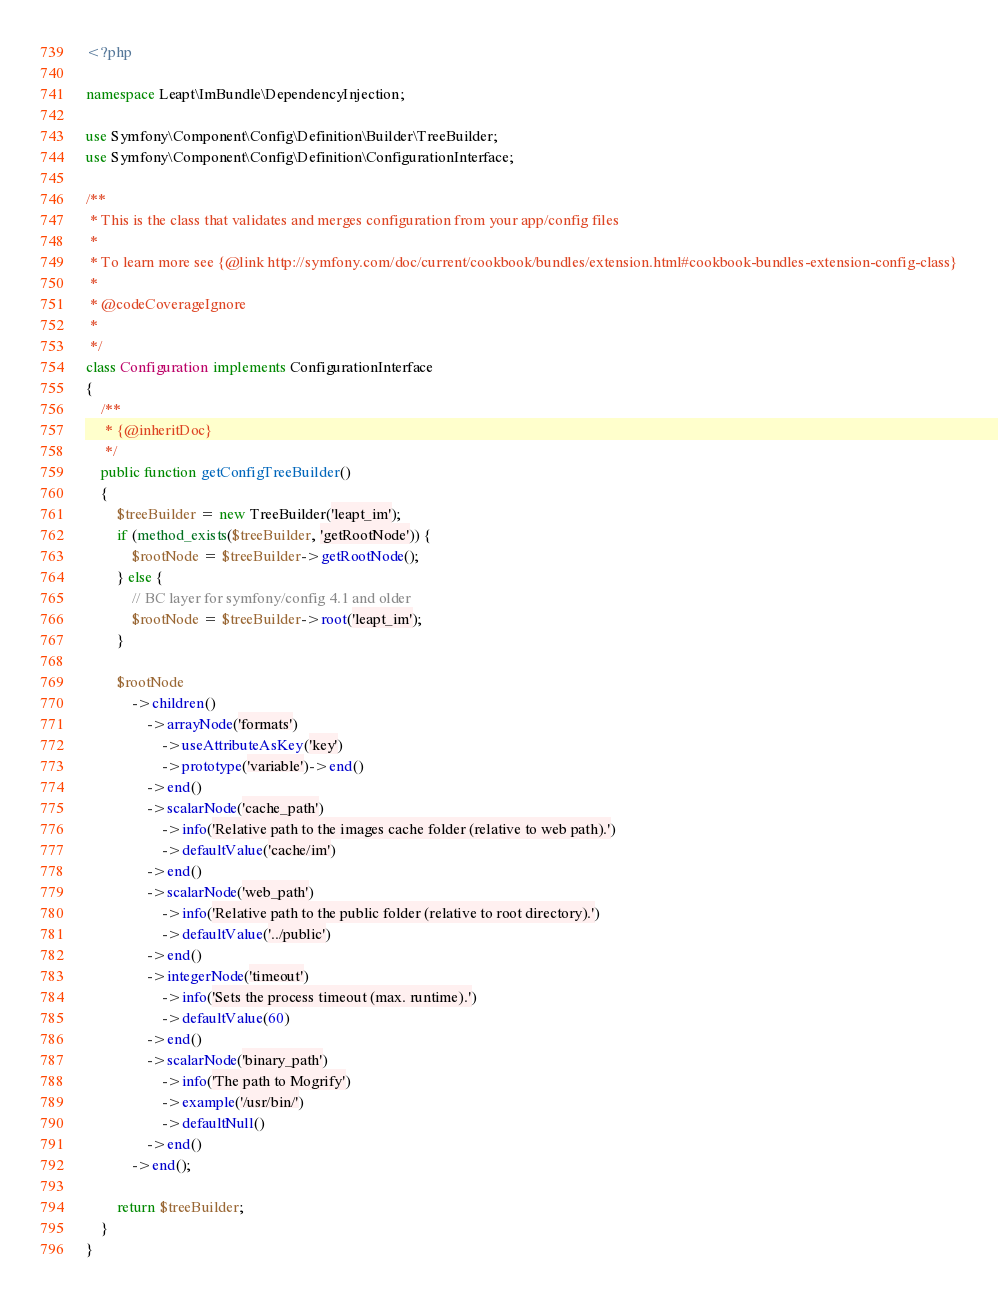<code> <loc_0><loc_0><loc_500><loc_500><_PHP_><?php

namespace Leapt\ImBundle\DependencyInjection;

use Symfony\Component\Config\Definition\Builder\TreeBuilder;
use Symfony\Component\Config\Definition\ConfigurationInterface;

/**
 * This is the class that validates and merges configuration from your app/config files
 *
 * To learn more see {@link http://symfony.com/doc/current/cookbook/bundles/extension.html#cookbook-bundles-extension-config-class}
 *
 * @codeCoverageIgnore
 *
 */
class Configuration implements ConfigurationInterface
{
    /**
     * {@inheritDoc}
     */
    public function getConfigTreeBuilder()
    {
        $treeBuilder = new TreeBuilder('leapt_im');
        if (method_exists($treeBuilder, 'getRootNode')) {
            $rootNode = $treeBuilder->getRootNode();
        } else {
            // BC layer for symfony/config 4.1 and older
            $rootNode = $treeBuilder->root('leapt_im');
        }

        $rootNode
            ->children()
                ->arrayNode('formats')
                    ->useAttributeAsKey('key')
                    ->prototype('variable')->end()
                ->end()
                ->scalarNode('cache_path')
                    ->info('Relative path to the images cache folder (relative to web path).')
                    ->defaultValue('cache/im')
                ->end()
                ->scalarNode('web_path')
                    ->info('Relative path to the public folder (relative to root directory).')
                    ->defaultValue('../public')
                ->end()
                ->integerNode('timeout')
                    ->info('Sets the process timeout (max. runtime).')
                    ->defaultValue(60)
                ->end()
                ->scalarNode('binary_path')
                    ->info('The path to Mogrify')
                    ->example('/usr/bin/')
                    ->defaultNull()
                ->end()
            ->end();

        return $treeBuilder;
    }
}
</code> 